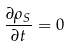<formula> <loc_0><loc_0><loc_500><loc_500>\frac { \partial \rho _ { S } } { \partial t } = 0</formula> 